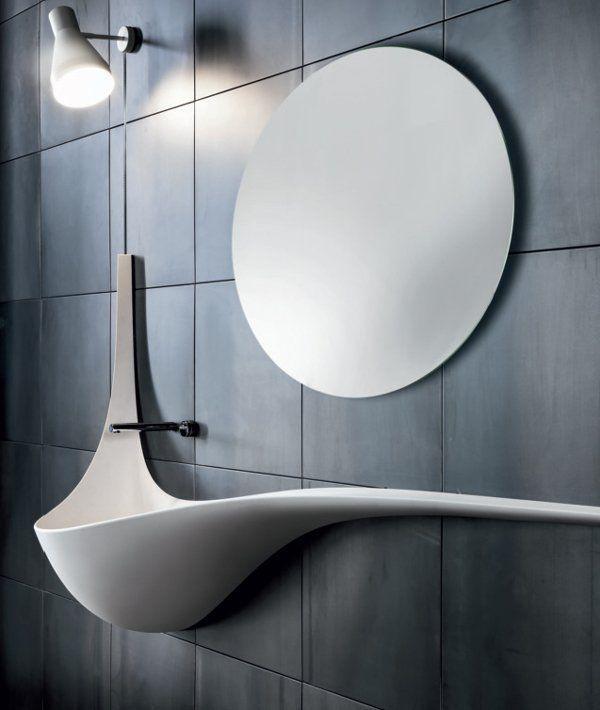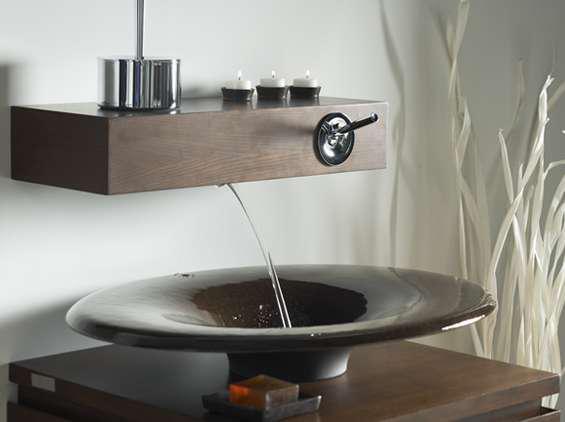The first image is the image on the left, the second image is the image on the right. Considering the images on both sides, is "A round mirror is above a sink." valid? Answer yes or no. Yes. The first image is the image on the left, the second image is the image on the right. Analyze the images presented: Is the assertion "A thin stream of water is flowing into a sink that sits atop a dark wood counter in one image." valid? Answer yes or no. Yes. 